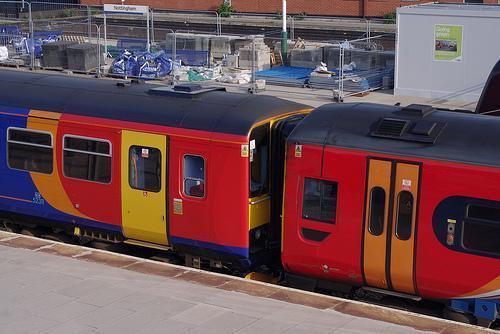How many train cars are there?
Give a very brief answer. 2. 